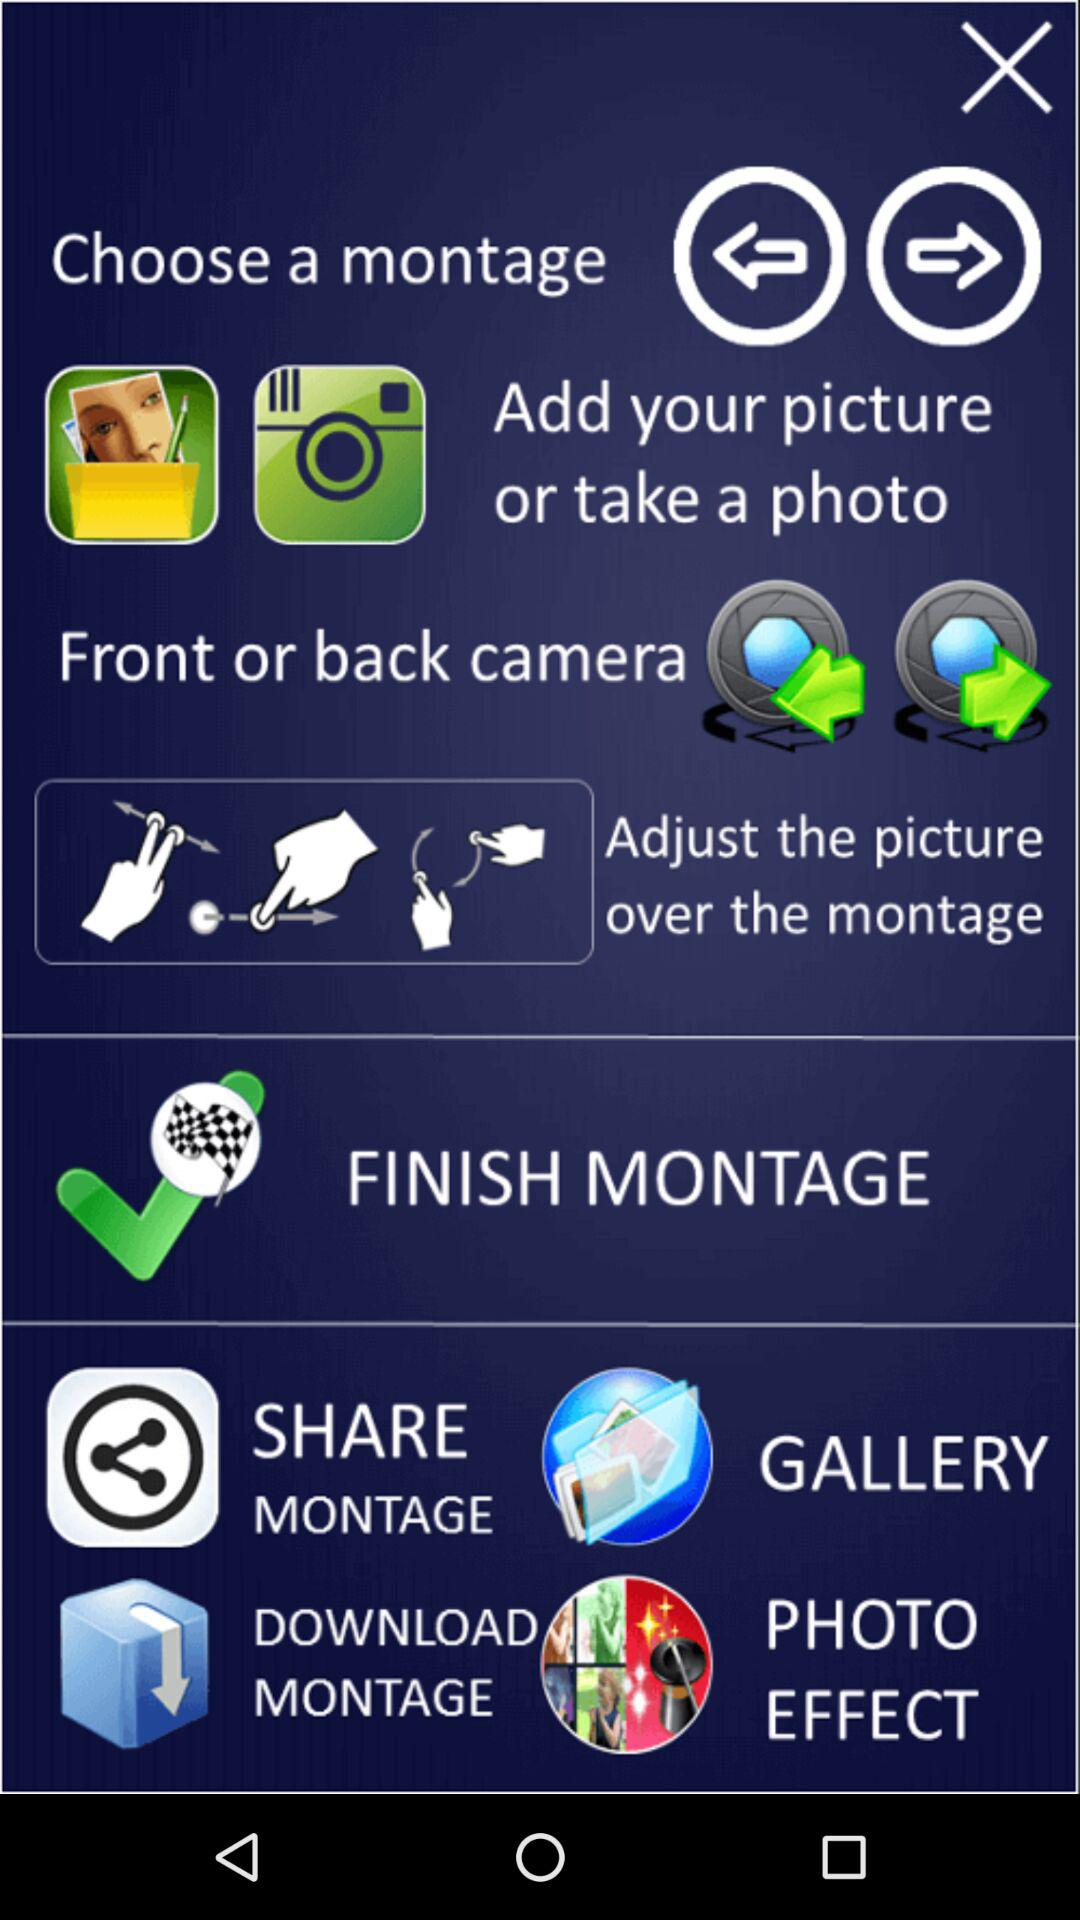How many images are in the gallery?
When the provided information is insufficient, respond with <no answer>. <no answer> 